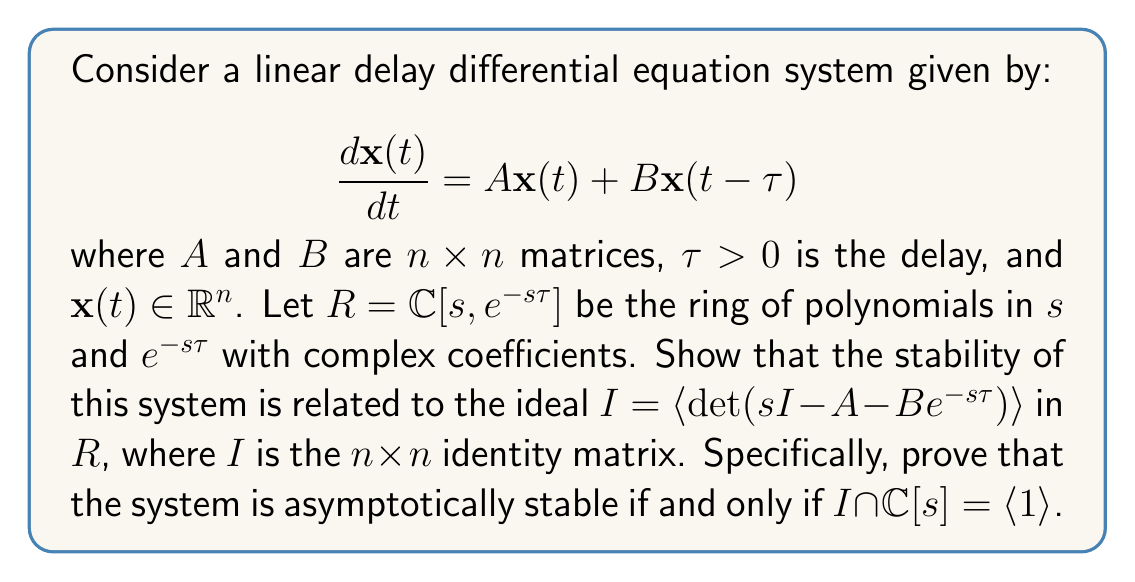Help me with this question. To prove this statement, we'll follow these steps:

1) First, recall that for a delay differential equation system, the characteristic equation is given by:

   $$\det(sI - A - Be^{-s\tau}) = 0$$

2) The stability of the system is determined by the roots of this characteristic equation. The system is asymptotically stable if and only if all roots have negative real parts.

3) Now, let's consider the ideal $I = \langle \det(sI - A - Be^{-s\tau}) \rangle$ in the ring $R = \mathbb{C}[s, e^{-s\tau}]$. This ideal contains all polynomials in $s$ and $e^{-s\tau}$ that are multiples of the characteristic equation.

4) The intersection $I \cap \mathbb{C}[s]$ represents all polynomials in $s$ alone (without $e^{-s\tau}$) that are in the ideal $I$. 

5) If $I \cap \mathbb{C}[s] = \langle 1 \rangle$, it means that the constant polynomial 1 is in this intersection. In other words, there exist polynomials $p(s, e^{-s\tau}) \in R$ and $q(s) \in \mathbb{C}[s]$ such that:

   $$p(s, e^{-s\tau}) \det(sI - A - Be^{-s\tau}) + q(s) = 1$$

6) This equation is known as a Bézout identity. In the context of stability analysis, it's equivalent to the concept of coprimeness over the ring of stable transfer functions.

7) If such an identity exists, it implies that $\det(sI - A - Be^{-s\tau})$ and $q(s)$ have no common roots in the closed right half-plane (including the imaginary axis). This is because any such common root would make both terms on the left side of the equation zero, which is impossible since the right side is 1.

8) Conversely, if the system is asymptotically stable, all roots of the characteristic equation have negative real parts. This means $\det(sI - A - Be^{-s\tau})$ is nonzero for all $s$ with non-negative real part. In this case, we can construct polynomials $p$ and $q$ satisfying the Bézout identity, proving that $I \cap \mathbb{C}[s] = \langle 1 \rangle$.

Therefore, the system is asymptotically stable if and only if $I \cap \mathbb{C}[s] = \langle 1 \rangle$.
Answer: The system is asymptotically stable if and only if $I \cap \mathbb{C}[s] = \langle 1 \rangle$, where $I = \langle \det(sI - A - Be^{-s\tau}) \rangle$ is the ideal generated by the characteristic equation in the ring $R = \mathbb{C}[s, e^{-s\tau}]$. 